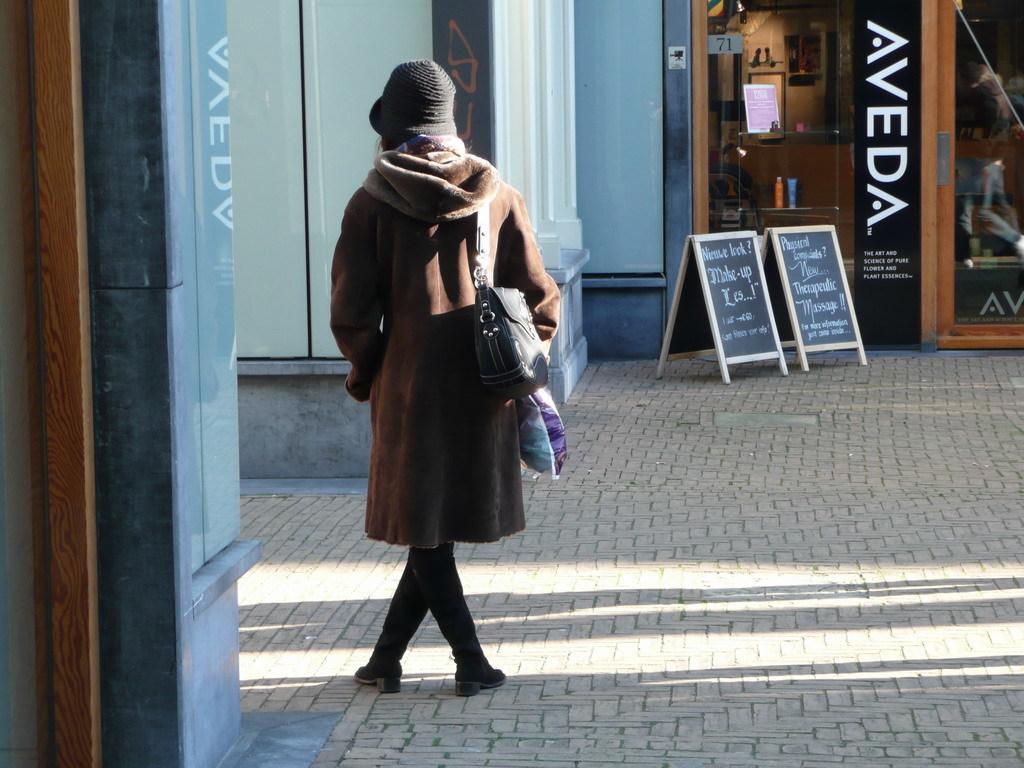In one or two sentences, can you explain what this image depicts? In this image we can see a person is standing on the road and carrying a bag on the shoulder and there is a cap on the head. In the background we can see the wall, glass doors, texts written on the boards on the road and through the glass doors we can see objects and wall. 